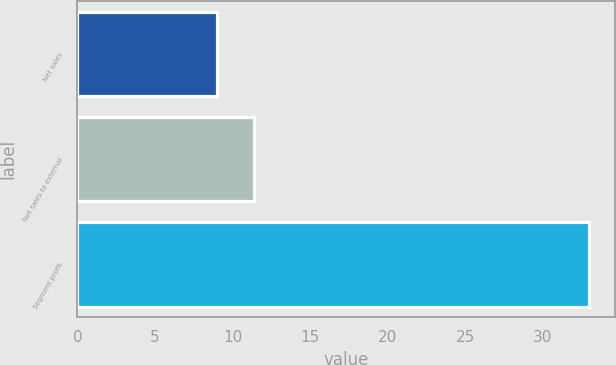Convert chart to OTSL. <chart><loc_0><loc_0><loc_500><loc_500><bar_chart><fcel>Net sales<fcel>Net sales to external<fcel>Segment profit<nl><fcel>9<fcel>11.4<fcel>33<nl></chart> 